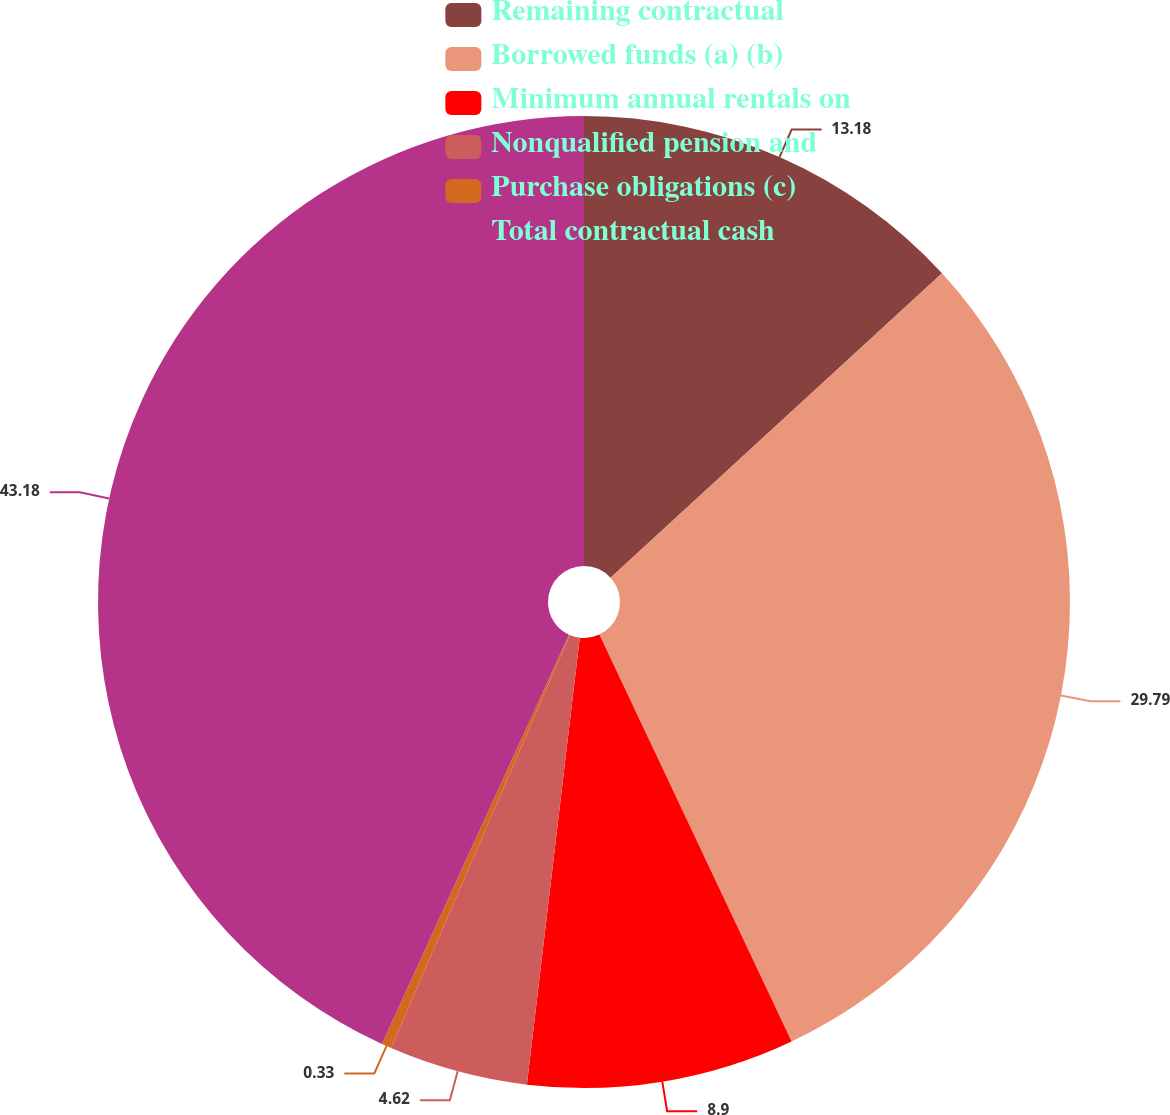Convert chart. <chart><loc_0><loc_0><loc_500><loc_500><pie_chart><fcel>Remaining contractual<fcel>Borrowed funds (a) (b)<fcel>Minimum annual rentals on<fcel>Nonqualified pension and<fcel>Purchase obligations (c)<fcel>Total contractual cash<nl><fcel>13.18%<fcel>29.79%<fcel>8.9%<fcel>4.62%<fcel>0.33%<fcel>43.17%<nl></chart> 